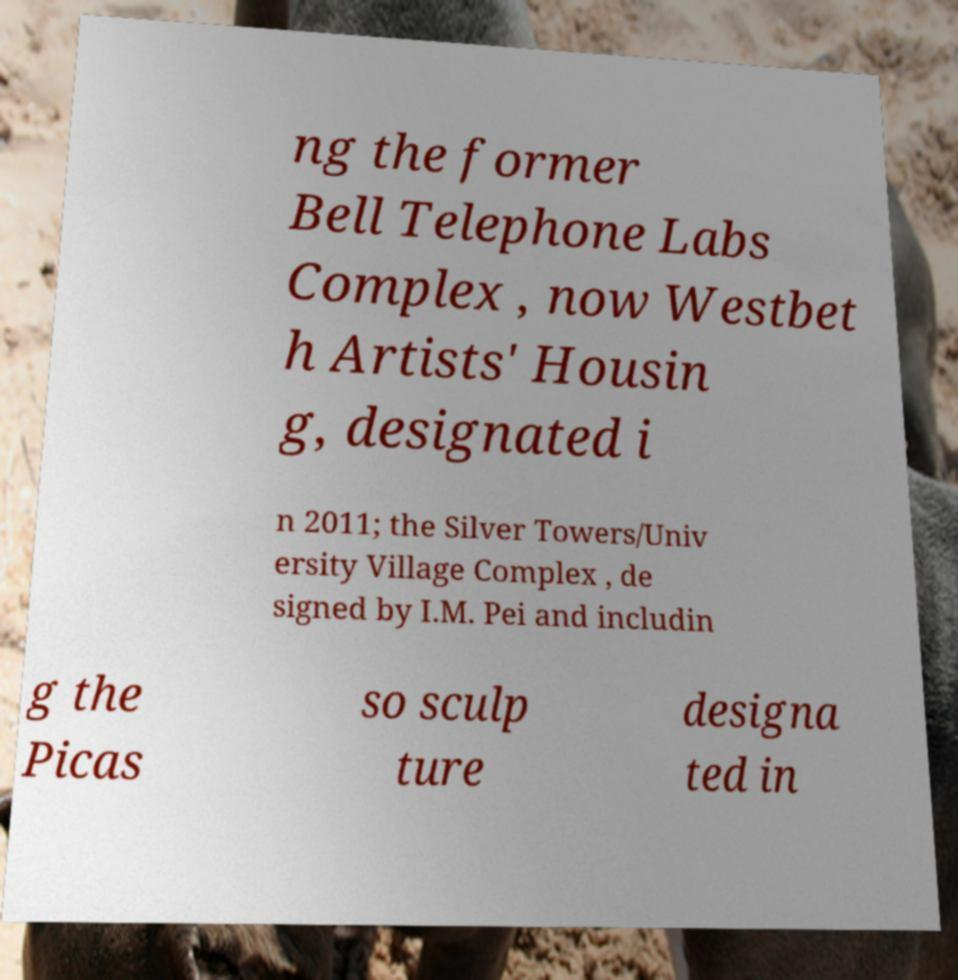Please read and relay the text visible in this image. What does it say? ng the former Bell Telephone Labs Complex , now Westbet h Artists' Housin g, designated i n 2011; the Silver Towers/Univ ersity Village Complex , de signed by I.M. Pei and includin g the Picas so sculp ture designa ted in 